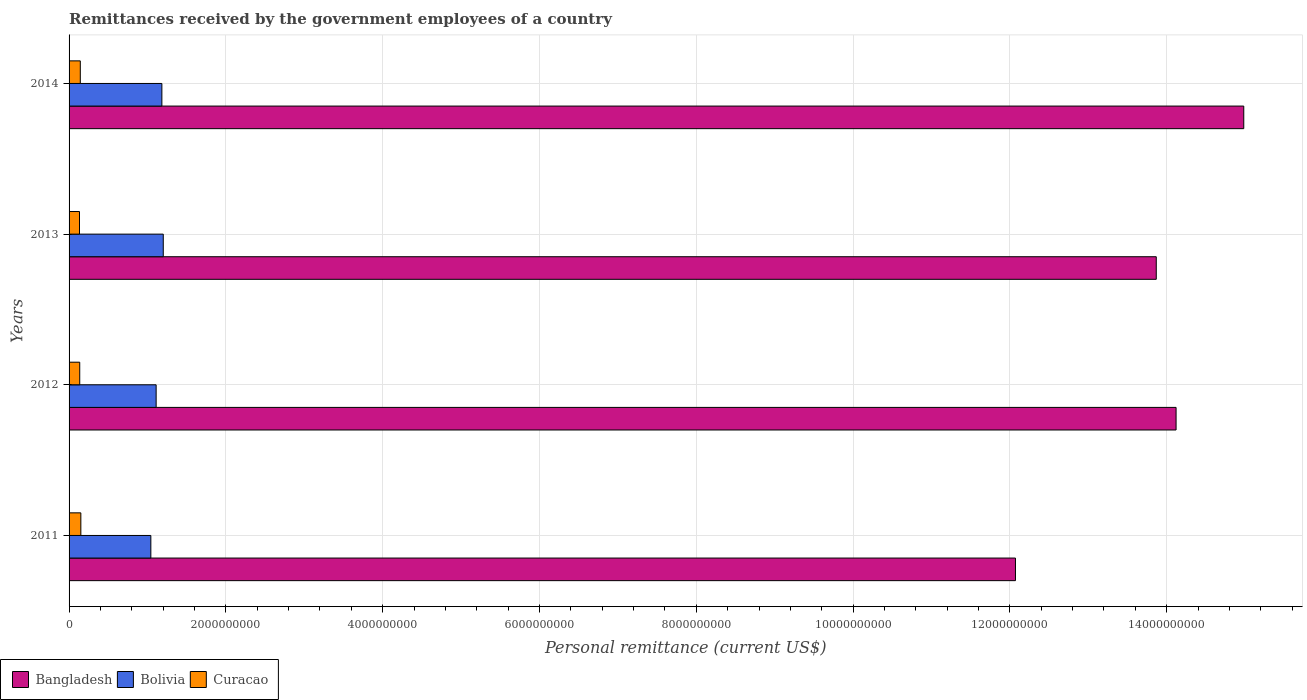How many different coloured bars are there?
Provide a short and direct response. 3. Are the number of bars on each tick of the Y-axis equal?
Offer a terse response. Yes. How many bars are there on the 4th tick from the bottom?
Your response must be concise. 3. In how many cases, is the number of bars for a given year not equal to the number of legend labels?
Offer a very short reply. 0. What is the remittances received by the government employees in Curacao in 2014?
Provide a short and direct response. 1.43e+08. Across all years, what is the maximum remittances received by the government employees in Bangladesh?
Your answer should be compact. 1.50e+1. Across all years, what is the minimum remittances received by the government employees in Bolivia?
Ensure brevity in your answer.  1.04e+09. In which year was the remittances received by the government employees in Bangladesh minimum?
Your answer should be compact. 2011. What is the total remittances received by the government employees in Bolivia in the graph?
Ensure brevity in your answer.  4.54e+09. What is the difference between the remittances received by the government employees in Bolivia in 2011 and that in 2013?
Offer a very short reply. -1.58e+08. What is the difference between the remittances received by the government employees in Bangladesh in 2011 and the remittances received by the government employees in Curacao in 2013?
Ensure brevity in your answer.  1.19e+1. What is the average remittances received by the government employees in Bolivia per year?
Provide a short and direct response. 1.13e+09. In the year 2013, what is the difference between the remittances received by the government employees in Bolivia and remittances received by the government employees in Bangladesh?
Offer a terse response. -1.27e+1. In how many years, is the remittances received by the government employees in Curacao greater than 1200000000 US$?
Keep it short and to the point. 0. What is the ratio of the remittances received by the government employees in Bangladesh in 2011 to that in 2013?
Provide a short and direct response. 0.87. Is the remittances received by the government employees in Bangladesh in 2012 less than that in 2014?
Offer a very short reply. Yes. What is the difference between the highest and the second highest remittances received by the government employees in Bangladesh?
Provide a succinct answer. 8.63e+08. What is the difference between the highest and the lowest remittances received by the government employees in Bangladesh?
Your answer should be very brief. 2.91e+09. In how many years, is the remittances received by the government employees in Bolivia greater than the average remittances received by the government employees in Bolivia taken over all years?
Offer a terse response. 2. Is it the case that in every year, the sum of the remittances received by the government employees in Bangladesh and remittances received by the government employees in Curacao is greater than the remittances received by the government employees in Bolivia?
Offer a terse response. Yes. How many bars are there?
Offer a terse response. 12. How many years are there in the graph?
Your response must be concise. 4. What is the difference between two consecutive major ticks on the X-axis?
Your answer should be very brief. 2.00e+09. Where does the legend appear in the graph?
Ensure brevity in your answer.  Bottom left. How many legend labels are there?
Keep it short and to the point. 3. What is the title of the graph?
Your answer should be very brief. Remittances received by the government employees of a country. Does "Kyrgyz Republic" appear as one of the legend labels in the graph?
Offer a very short reply. No. What is the label or title of the X-axis?
Make the answer very short. Personal remittance (current US$). What is the label or title of the Y-axis?
Give a very brief answer. Years. What is the Personal remittance (current US$) in Bangladesh in 2011?
Ensure brevity in your answer.  1.21e+1. What is the Personal remittance (current US$) in Bolivia in 2011?
Provide a short and direct response. 1.04e+09. What is the Personal remittance (current US$) in Curacao in 2011?
Ensure brevity in your answer.  1.50e+08. What is the Personal remittance (current US$) of Bangladesh in 2012?
Provide a short and direct response. 1.41e+1. What is the Personal remittance (current US$) of Bolivia in 2012?
Provide a short and direct response. 1.11e+09. What is the Personal remittance (current US$) of Curacao in 2012?
Your response must be concise. 1.36e+08. What is the Personal remittance (current US$) in Bangladesh in 2013?
Your response must be concise. 1.39e+1. What is the Personal remittance (current US$) in Bolivia in 2013?
Your answer should be very brief. 1.20e+09. What is the Personal remittance (current US$) in Curacao in 2013?
Offer a very short reply. 1.33e+08. What is the Personal remittance (current US$) of Bangladesh in 2014?
Make the answer very short. 1.50e+1. What is the Personal remittance (current US$) in Bolivia in 2014?
Your response must be concise. 1.18e+09. What is the Personal remittance (current US$) in Curacao in 2014?
Keep it short and to the point. 1.43e+08. Across all years, what is the maximum Personal remittance (current US$) of Bangladesh?
Your response must be concise. 1.50e+1. Across all years, what is the maximum Personal remittance (current US$) in Bolivia?
Provide a succinct answer. 1.20e+09. Across all years, what is the maximum Personal remittance (current US$) of Curacao?
Your answer should be very brief. 1.50e+08. Across all years, what is the minimum Personal remittance (current US$) in Bangladesh?
Your answer should be very brief. 1.21e+1. Across all years, what is the minimum Personal remittance (current US$) of Bolivia?
Your answer should be compact. 1.04e+09. Across all years, what is the minimum Personal remittance (current US$) of Curacao?
Provide a succinct answer. 1.33e+08. What is the total Personal remittance (current US$) in Bangladesh in the graph?
Offer a terse response. 5.50e+1. What is the total Personal remittance (current US$) of Bolivia in the graph?
Offer a very short reply. 4.54e+09. What is the total Personal remittance (current US$) of Curacao in the graph?
Your response must be concise. 5.62e+08. What is the difference between the Personal remittance (current US$) in Bangladesh in 2011 and that in 2012?
Make the answer very short. -2.05e+09. What is the difference between the Personal remittance (current US$) of Bolivia in 2011 and that in 2012?
Offer a very short reply. -6.75e+07. What is the difference between the Personal remittance (current US$) in Curacao in 2011 and that in 2012?
Provide a succinct answer. 1.42e+07. What is the difference between the Personal remittance (current US$) of Bangladesh in 2011 and that in 2013?
Make the answer very short. -1.80e+09. What is the difference between the Personal remittance (current US$) in Bolivia in 2011 and that in 2013?
Provide a succinct answer. -1.58e+08. What is the difference between the Personal remittance (current US$) in Curacao in 2011 and that in 2013?
Your response must be concise. 1.71e+07. What is the difference between the Personal remittance (current US$) in Bangladesh in 2011 and that in 2014?
Make the answer very short. -2.91e+09. What is the difference between the Personal remittance (current US$) of Bolivia in 2011 and that in 2014?
Your answer should be very brief. -1.41e+08. What is the difference between the Personal remittance (current US$) of Curacao in 2011 and that in 2014?
Provide a succinct answer. 6.85e+06. What is the difference between the Personal remittance (current US$) in Bangladesh in 2012 and that in 2013?
Keep it short and to the point. 2.53e+08. What is the difference between the Personal remittance (current US$) in Bolivia in 2012 and that in 2013?
Provide a succinct answer. -9.08e+07. What is the difference between the Personal remittance (current US$) in Curacao in 2012 and that in 2013?
Give a very brief answer. 2.91e+06. What is the difference between the Personal remittance (current US$) in Bangladesh in 2012 and that in 2014?
Give a very brief answer. -8.63e+08. What is the difference between the Personal remittance (current US$) of Bolivia in 2012 and that in 2014?
Provide a succinct answer. -7.31e+07. What is the difference between the Personal remittance (current US$) in Curacao in 2012 and that in 2014?
Provide a succinct answer. -7.31e+06. What is the difference between the Personal remittance (current US$) of Bangladesh in 2013 and that in 2014?
Offer a terse response. -1.12e+09. What is the difference between the Personal remittance (current US$) in Bolivia in 2013 and that in 2014?
Your answer should be very brief. 1.77e+07. What is the difference between the Personal remittance (current US$) of Curacao in 2013 and that in 2014?
Provide a short and direct response. -1.02e+07. What is the difference between the Personal remittance (current US$) in Bangladesh in 2011 and the Personal remittance (current US$) in Bolivia in 2012?
Make the answer very short. 1.10e+1. What is the difference between the Personal remittance (current US$) in Bangladesh in 2011 and the Personal remittance (current US$) in Curacao in 2012?
Keep it short and to the point. 1.19e+1. What is the difference between the Personal remittance (current US$) of Bolivia in 2011 and the Personal remittance (current US$) of Curacao in 2012?
Give a very brief answer. 9.07e+08. What is the difference between the Personal remittance (current US$) of Bangladesh in 2011 and the Personal remittance (current US$) of Bolivia in 2013?
Offer a very short reply. 1.09e+1. What is the difference between the Personal remittance (current US$) of Bangladesh in 2011 and the Personal remittance (current US$) of Curacao in 2013?
Offer a very short reply. 1.19e+1. What is the difference between the Personal remittance (current US$) in Bolivia in 2011 and the Personal remittance (current US$) in Curacao in 2013?
Offer a terse response. 9.10e+08. What is the difference between the Personal remittance (current US$) of Bangladesh in 2011 and the Personal remittance (current US$) of Bolivia in 2014?
Offer a very short reply. 1.09e+1. What is the difference between the Personal remittance (current US$) of Bangladesh in 2011 and the Personal remittance (current US$) of Curacao in 2014?
Give a very brief answer. 1.19e+1. What is the difference between the Personal remittance (current US$) of Bolivia in 2011 and the Personal remittance (current US$) of Curacao in 2014?
Ensure brevity in your answer.  9.00e+08. What is the difference between the Personal remittance (current US$) of Bangladesh in 2012 and the Personal remittance (current US$) of Bolivia in 2013?
Offer a very short reply. 1.29e+1. What is the difference between the Personal remittance (current US$) of Bangladesh in 2012 and the Personal remittance (current US$) of Curacao in 2013?
Offer a terse response. 1.40e+1. What is the difference between the Personal remittance (current US$) in Bolivia in 2012 and the Personal remittance (current US$) in Curacao in 2013?
Make the answer very short. 9.77e+08. What is the difference between the Personal remittance (current US$) in Bangladesh in 2012 and the Personal remittance (current US$) in Bolivia in 2014?
Your answer should be very brief. 1.29e+1. What is the difference between the Personal remittance (current US$) of Bangladesh in 2012 and the Personal remittance (current US$) of Curacao in 2014?
Provide a short and direct response. 1.40e+1. What is the difference between the Personal remittance (current US$) of Bolivia in 2012 and the Personal remittance (current US$) of Curacao in 2014?
Provide a succinct answer. 9.67e+08. What is the difference between the Personal remittance (current US$) of Bangladesh in 2013 and the Personal remittance (current US$) of Bolivia in 2014?
Your response must be concise. 1.27e+1. What is the difference between the Personal remittance (current US$) in Bangladesh in 2013 and the Personal remittance (current US$) in Curacao in 2014?
Offer a very short reply. 1.37e+1. What is the difference between the Personal remittance (current US$) of Bolivia in 2013 and the Personal remittance (current US$) of Curacao in 2014?
Offer a very short reply. 1.06e+09. What is the average Personal remittance (current US$) in Bangladesh per year?
Provide a short and direct response. 1.38e+1. What is the average Personal remittance (current US$) of Bolivia per year?
Provide a succinct answer. 1.13e+09. What is the average Personal remittance (current US$) of Curacao per year?
Provide a succinct answer. 1.41e+08. In the year 2011, what is the difference between the Personal remittance (current US$) of Bangladesh and Personal remittance (current US$) of Bolivia?
Provide a short and direct response. 1.10e+1. In the year 2011, what is the difference between the Personal remittance (current US$) of Bangladesh and Personal remittance (current US$) of Curacao?
Provide a succinct answer. 1.19e+1. In the year 2011, what is the difference between the Personal remittance (current US$) of Bolivia and Personal remittance (current US$) of Curacao?
Your answer should be compact. 8.93e+08. In the year 2012, what is the difference between the Personal remittance (current US$) of Bangladesh and Personal remittance (current US$) of Bolivia?
Provide a short and direct response. 1.30e+1. In the year 2012, what is the difference between the Personal remittance (current US$) in Bangladesh and Personal remittance (current US$) in Curacao?
Your answer should be compact. 1.40e+1. In the year 2012, what is the difference between the Personal remittance (current US$) in Bolivia and Personal remittance (current US$) in Curacao?
Offer a very short reply. 9.75e+08. In the year 2013, what is the difference between the Personal remittance (current US$) of Bangladesh and Personal remittance (current US$) of Bolivia?
Give a very brief answer. 1.27e+1. In the year 2013, what is the difference between the Personal remittance (current US$) of Bangladesh and Personal remittance (current US$) of Curacao?
Provide a short and direct response. 1.37e+1. In the year 2013, what is the difference between the Personal remittance (current US$) of Bolivia and Personal remittance (current US$) of Curacao?
Your answer should be compact. 1.07e+09. In the year 2014, what is the difference between the Personal remittance (current US$) in Bangladesh and Personal remittance (current US$) in Bolivia?
Offer a very short reply. 1.38e+1. In the year 2014, what is the difference between the Personal remittance (current US$) in Bangladesh and Personal remittance (current US$) in Curacao?
Make the answer very short. 1.48e+1. In the year 2014, what is the difference between the Personal remittance (current US$) in Bolivia and Personal remittance (current US$) in Curacao?
Your answer should be very brief. 1.04e+09. What is the ratio of the Personal remittance (current US$) of Bangladesh in 2011 to that in 2012?
Give a very brief answer. 0.85. What is the ratio of the Personal remittance (current US$) of Bolivia in 2011 to that in 2012?
Make the answer very short. 0.94. What is the ratio of the Personal remittance (current US$) of Curacao in 2011 to that in 2012?
Offer a terse response. 1.1. What is the ratio of the Personal remittance (current US$) in Bangladesh in 2011 to that in 2013?
Ensure brevity in your answer.  0.87. What is the ratio of the Personal remittance (current US$) of Bolivia in 2011 to that in 2013?
Offer a very short reply. 0.87. What is the ratio of the Personal remittance (current US$) in Curacao in 2011 to that in 2013?
Your answer should be very brief. 1.13. What is the ratio of the Personal remittance (current US$) in Bangladesh in 2011 to that in 2014?
Make the answer very short. 0.81. What is the ratio of the Personal remittance (current US$) of Bolivia in 2011 to that in 2014?
Make the answer very short. 0.88. What is the ratio of the Personal remittance (current US$) in Curacao in 2011 to that in 2014?
Your answer should be very brief. 1.05. What is the ratio of the Personal remittance (current US$) in Bangladesh in 2012 to that in 2013?
Provide a succinct answer. 1.02. What is the ratio of the Personal remittance (current US$) of Bolivia in 2012 to that in 2013?
Offer a terse response. 0.92. What is the ratio of the Personal remittance (current US$) in Curacao in 2012 to that in 2013?
Ensure brevity in your answer.  1.02. What is the ratio of the Personal remittance (current US$) of Bangladesh in 2012 to that in 2014?
Ensure brevity in your answer.  0.94. What is the ratio of the Personal remittance (current US$) in Bolivia in 2012 to that in 2014?
Make the answer very short. 0.94. What is the ratio of the Personal remittance (current US$) in Curacao in 2012 to that in 2014?
Your response must be concise. 0.95. What is the ratio of the Personal remittance (current US$) in Bangladesh in 2013 to that in 2014?
Provide a succinct answer. 0.93. What is the ratio of the Personal remittance (current US$) in Curacao in 2013 to that in 2014?
Your response must be concise. 0.93. What is the difference between the highest and the second highest Personal remittance (current US$) in Bangladesh?
Your response must be concise. 8.63e+08. What is the difference between the highest and the second highest Personal remittance (current US$) in Bolivia?
Your answer should be very brief. 1.77e+07. What is the difference between the highest and the second highest Personal remittance (current US$) in Curacao?
Give a very brief answer. 6.85e+06. What is the difference between the highest and the lowest Personal remittance (current US$) of Bangladesh?
Your response must be concise. 2.91e+09. What is the difference between the highest and the lowest Personal remittance (current US$) of Bolivia?
Your answer should be very brief. 1.58e+08. What is the difference between the highest and the lowest Personal remittance (current US$) of Curacao?
Provide a short and direct response. 1.71e+07. 